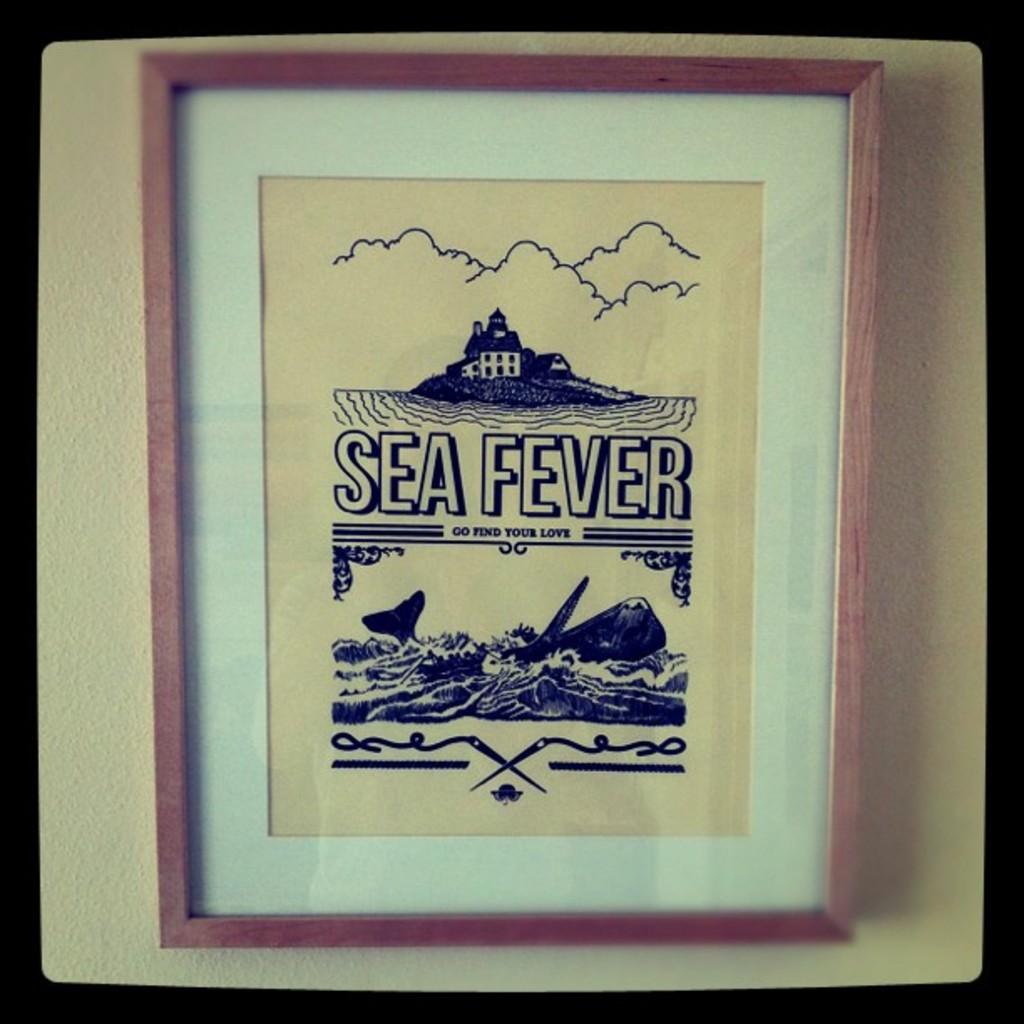What kind of fever?
Make the answer very short. Sea. What sickness is this?
Your answer should be very brief. Sea fever. 